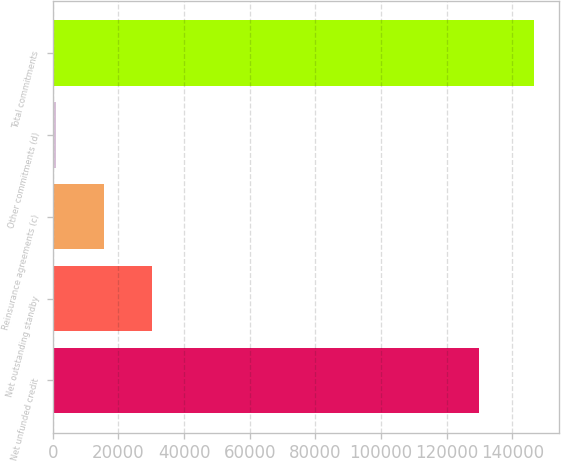<chart> <loc_0><loc_0><loc_500><loc_500><bar_chart><fcel>Net unfunded credit<fcel>Net outstanding standby<fcel>Reinsurance agreements (c)<fcel>Other commitments (d)<fcel>Total commitments<nl><fcel>129870<fcel>30179.2<fcel>15606.6<fcel>1034<fcel>146760<nl></chart> 